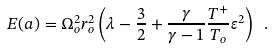<formula> <loc_0><loc_0><loc_500><loc_500>E ( a ) = \Omega _ { o } ^ { 2 } r _ { o } ^ { 2 } \left ( \lambda - \frac { 3 } { 2 } + \frac { \gamma } { \gamma - 1 } \frac { T ^ { + } } { T _ { o } } \varepsilon ^ { 2 } \right ) \ .</formula> 